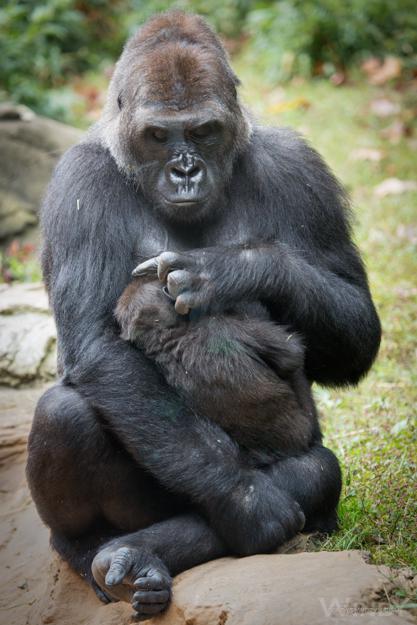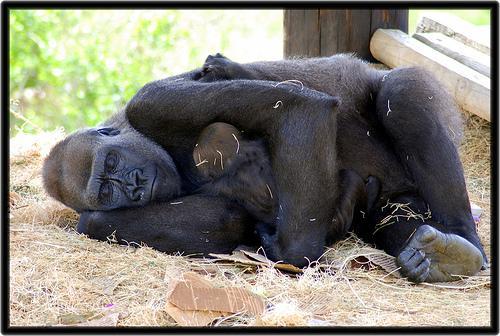The first image is the image on the left, the second image is the image on the right. For the images shown, is this caption "The left image shows a mother gorilla nursing her baby, sitting with her back to the left and her head raised and turned to gaze somewhat forward." true? Answer yes or no. No. 